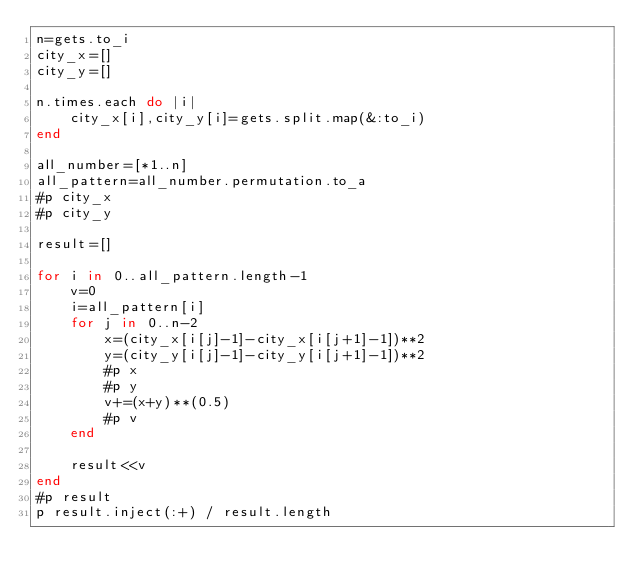Convert code to text. <code><loc_0><loc_0><loc_500><loc_500><_Ruby_>n=gets.to_i
city_x=[]
city_y=[]

n.times.each do |i|
    city_x[i],city_y[i]=gets.split.map(&:to_i)
end

all_number=[*1..n]
all_pattern=all_number.permutation.to_a
#p city_x
#p city_y

result=[]

for i in 0..all_pattern.length-1
    v=0
    i=all_pattern[i]
    for j in 0..n-2
        x=(city_x[i[j]-1]-city_x[i[j+1]-1])**2
        y=(city_y[i[j]-1]-city_y[i[j+1]-1])**2
        #p x
        #p y
        v+=(x+y)**(0.5)
        #p v
    end
    
    result<<v
end
#p result
p result.inject(:+) / result.length
</code> 